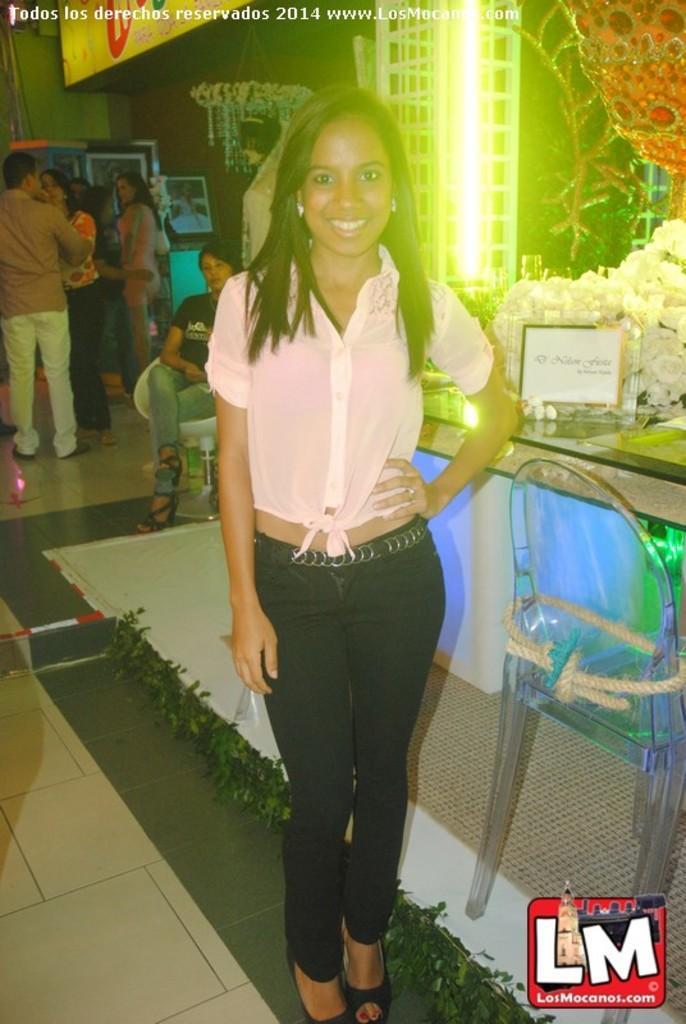In one or two sentences, can you explain what this image depicts? There is a woman standing on the floor and smiling,beside her we can see chair and board and flowers on the table. We can see green leaves and decorative object. In the background we can see people,chair,frames,wall and chandelier. At the top we can see text. In the bottom right side of the image we can see logo. 